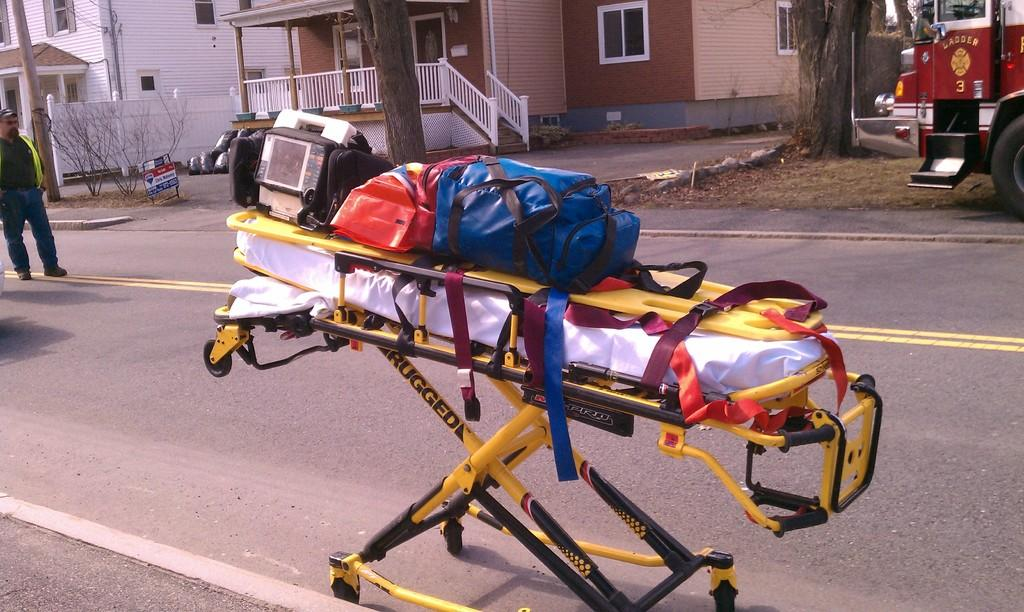What is the main object in the center of the image? There is a stretcher in the center of the image. What is placed on the stretcher? There is luggage on the stretcher. Can you describe the background of the image? There are trees, houses, and a vehicle in the background of the image. Are there any people visible in the image? Yes, there is a person in the background of the image. How does the alley increase in size in the image? There is no alley present in the image; it features a stretcher with luggage, a person, and a background with trees, houses, and a vehicle. What type of coal can be seen in the image? There is no coal present in the image. 